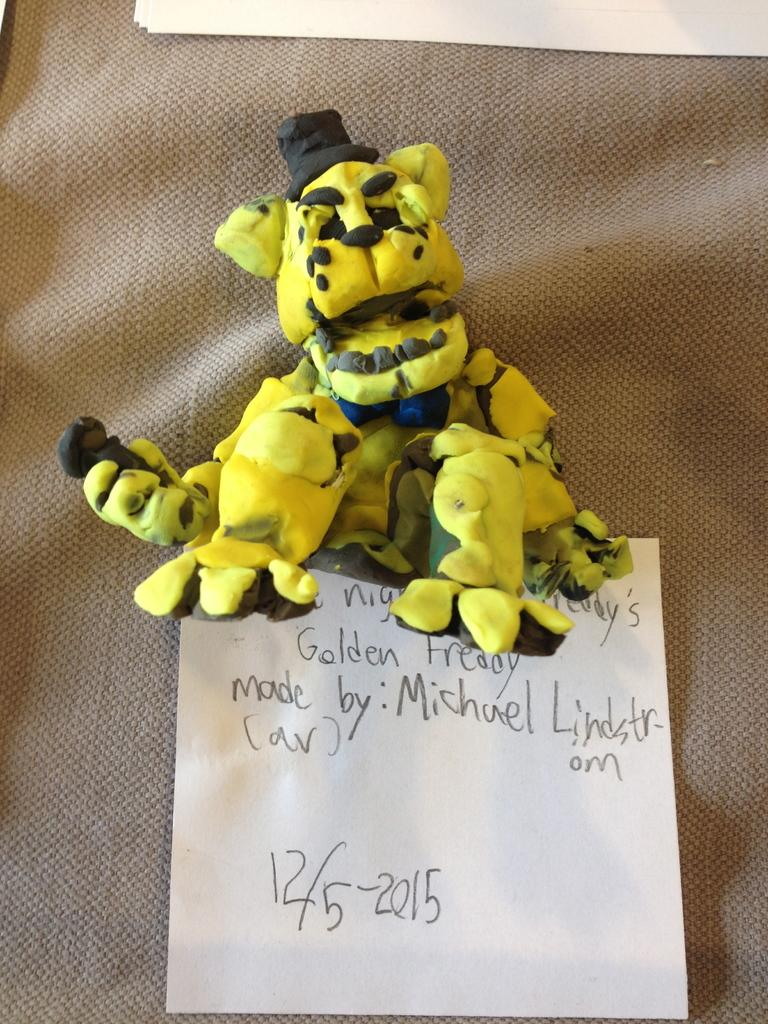What type of object is in the image? There is a toy animal in the image. Can you describe the toy animal's appearance? The toy animal is yellow and black in color. What else can be seen in the image besides the toy animal? There is a white paper in the image. On what surface is the white paper placed? The white paper is on a cream-colored surface. What is the condition of the grandfather's health in the image? There is no mention of a grandfather or any health condition in the image. 